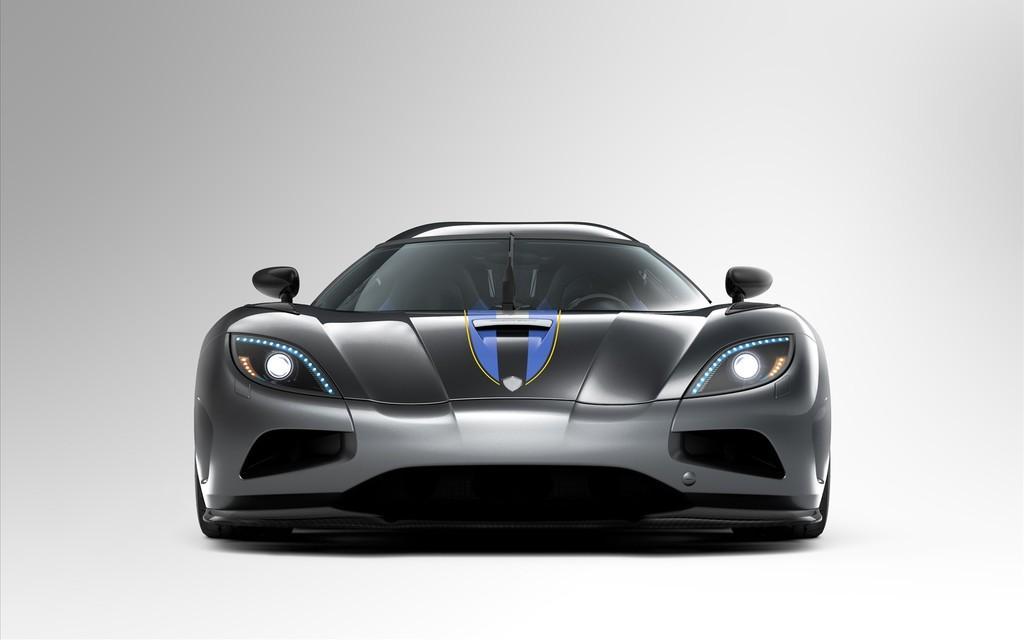Can you describe this image briefly? In the center of the picture there is a car in grey color. 